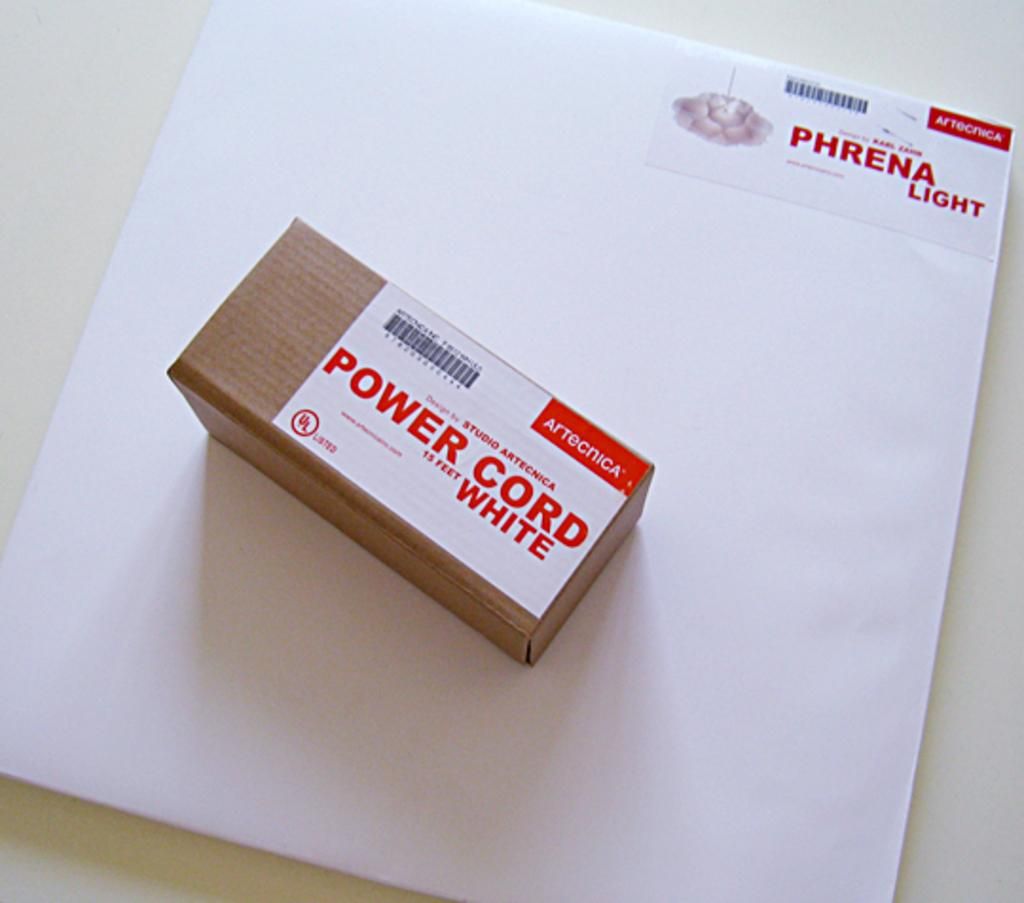<image>
Write a terse but informative summary of the picture. A pack of white Phrena Light and a small box of white power cord. 